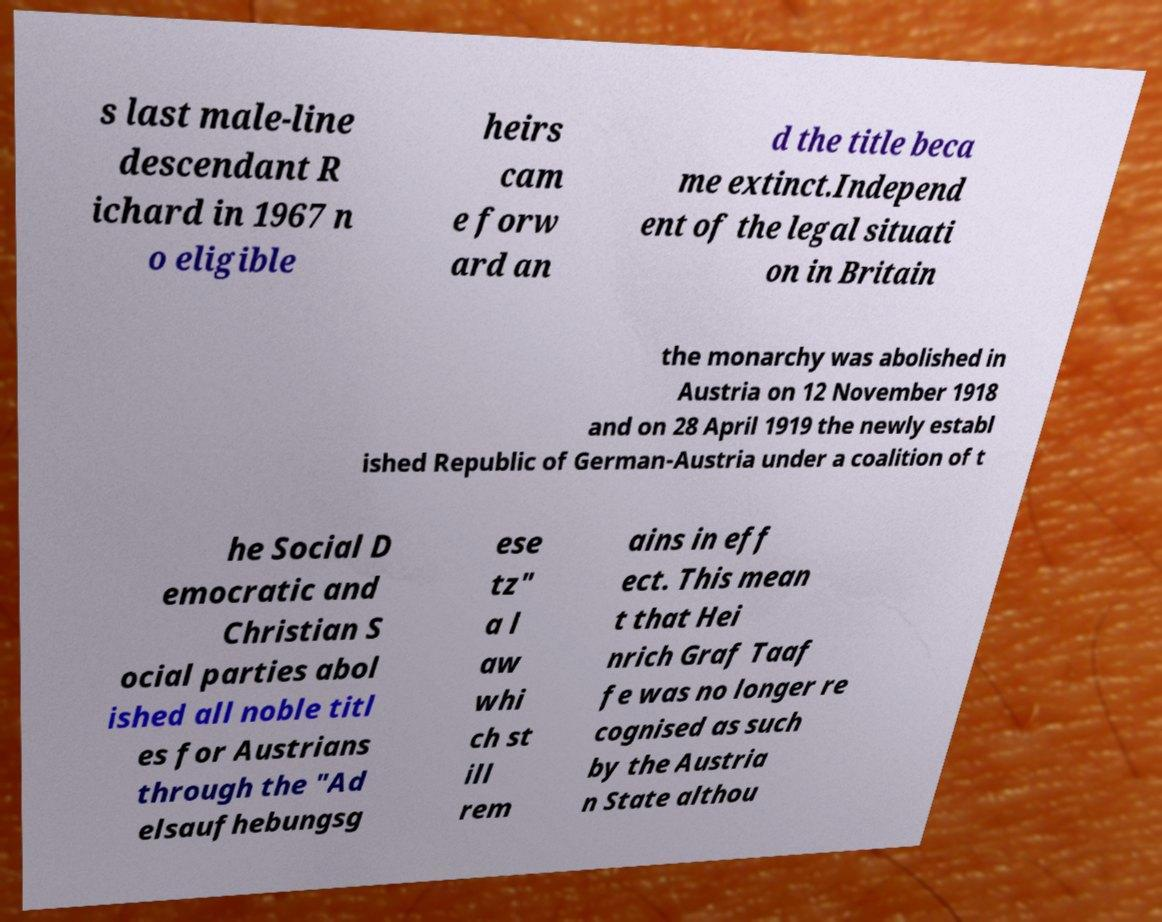Could you assist in decoding the text presented in this image and type it out clearly? s last male-line descendant R ichard in 1967 n o eligible heirs cam e forw ard an d the title beca me extinct.Independ ent of the legal situati on in Britain the monarchy was abolished in Austria on 12 November 1918 and on 28 April 1919 the newly establ ished Republic of German-Austria under a coalition of t he Social D emocratic and Christian S ocial parties abol ished all noble titl es for Austrians through the "Ad elsaufhebungsg ese tz" a l aw whi ch st ill rem ains in eff ect. This mean t that Hei nrich Graf Taaf fe was no longer re cognised as such by the Austria n State althou 